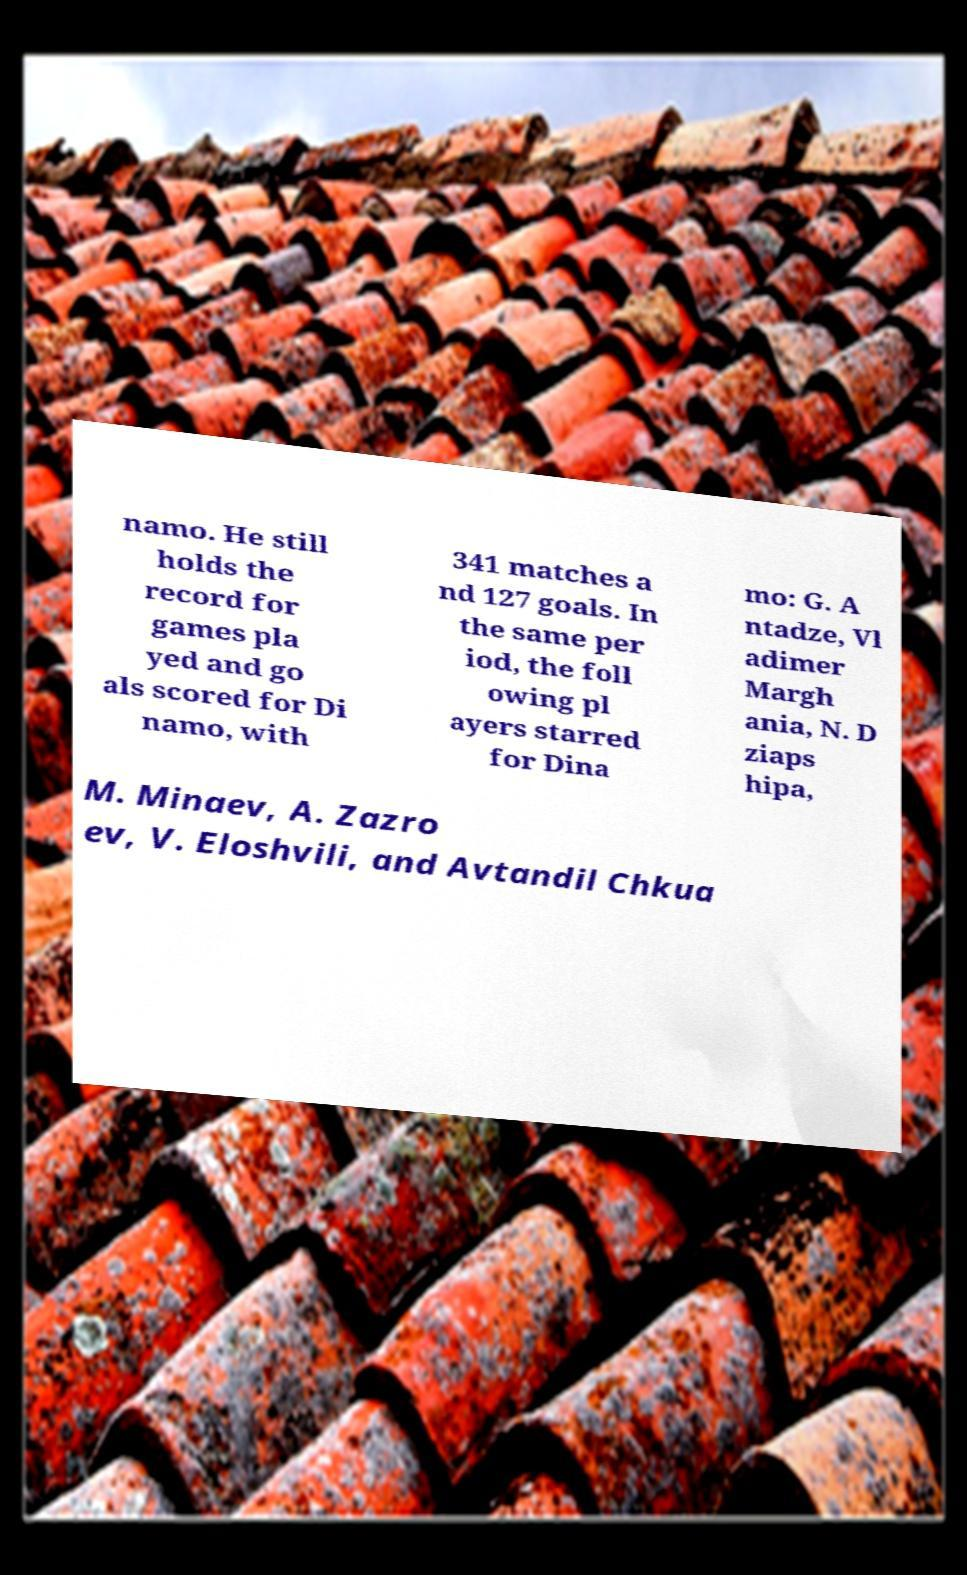For documentation purposes, I need the text within this image transcribed. Could you provide that? namo. He still holds the record for games pla yed and go als scored for Di namo, with 341 matches a nd 127 goals. In the same per iod, the foll owing pl ayers starred for Dina mo: G. A ntadze, Vl adimer Margh ania, N. D ziaps hipa, M. Minaev, A. Zazro ev, V. Eloshvili, and Avtandil Chkua 